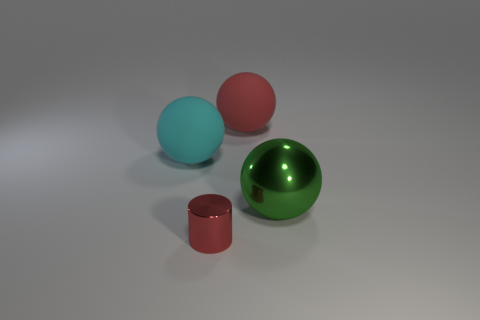There is another thing that is the same material as the large red thing; what shape is it?
Offer a very short reply. Sphere. Are there any red objects that are in front of the rubber thing behind the large cyan thing?
Provide a succinct answer. Yes. How big is the cylinder?
Make the answer very short. Small. How many objects are either green cylinders or spheres?
Ensure brevity in your answer.  3. Are the large sphere that is to the left of the red cylinder and the red thing that is on the right side of the small red thing made of the same material?
Ensure brevity in your answer.  Yes. What is the color of the large ball that is made of the same material as the tiny red object?
Your answer should be compact. Green. How many green balls have the same size as the red rubber ball?
Your response must be concise. 1. What number of other things are there of the same color as the metallic cylinder?
Your response must be concise. 1. Are there any other things that are the same size as the green thing?
Ensure brevity in your answer.  Yes. Do the red thing in front of the red rubber thing and the red object behind the green metallic object have the same shape?
Offer a very short reply. No. 